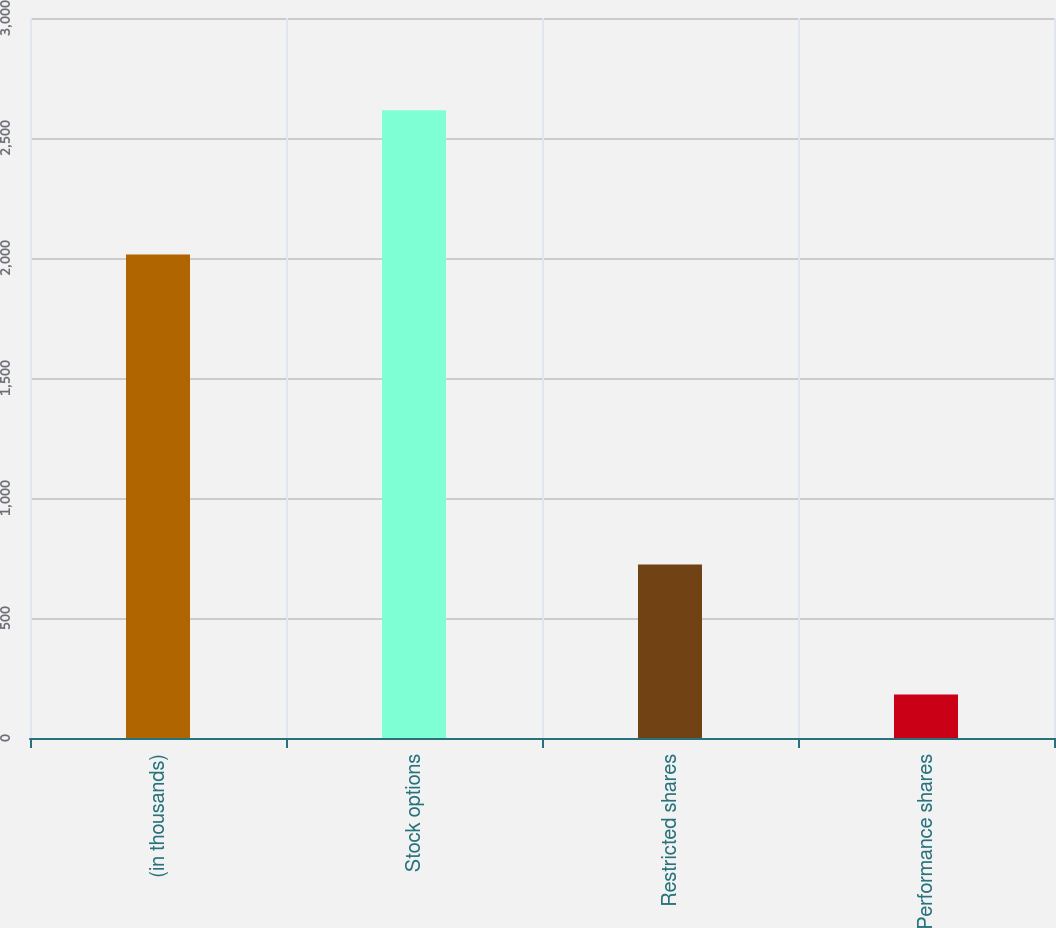Convert chart to OTSL. <chart><loc_0><loc_0><loc_500><loc_500><bar_chart><fcel>(in thousands)<fcel>Stock options<fcel>Restricted shares<fcel>Performance shares<nl><fcel>2015<fcel>2616<fcel>723<fcel>181<nl></chart> 